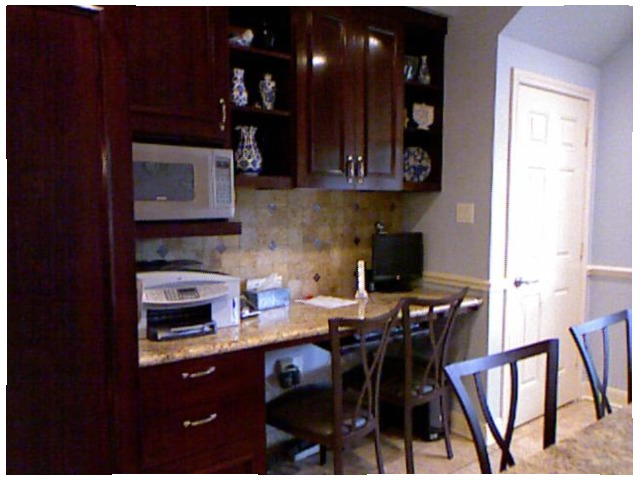<image>
Can you confirm if the counter top is on the chair? No. The counter top is not positioned on the chair. They may be near each other, but the counter top is not supported by or resting on top of the chair. Is the light in the microwave? No. The light is not contained within the microwave. These objects have a different spatial relationship. 